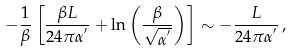Convert formula to latex. <formula><loc_0><loc_0><loc_500><loc_500>- \frac { 1 } { \beta } \left [ \frac { \beta L } { 2 4 \pi \alpha ^ { ^ { \prime } } } + \ln { \left ( \frac { \beta } { \sqrt { \alpha ^ { ^ { \prime } } } } \right ) } \right ] \sim - \frac { L } { 2 4 \pi \alpha ^ { ^ { \prime } } } \, ,</formula> 